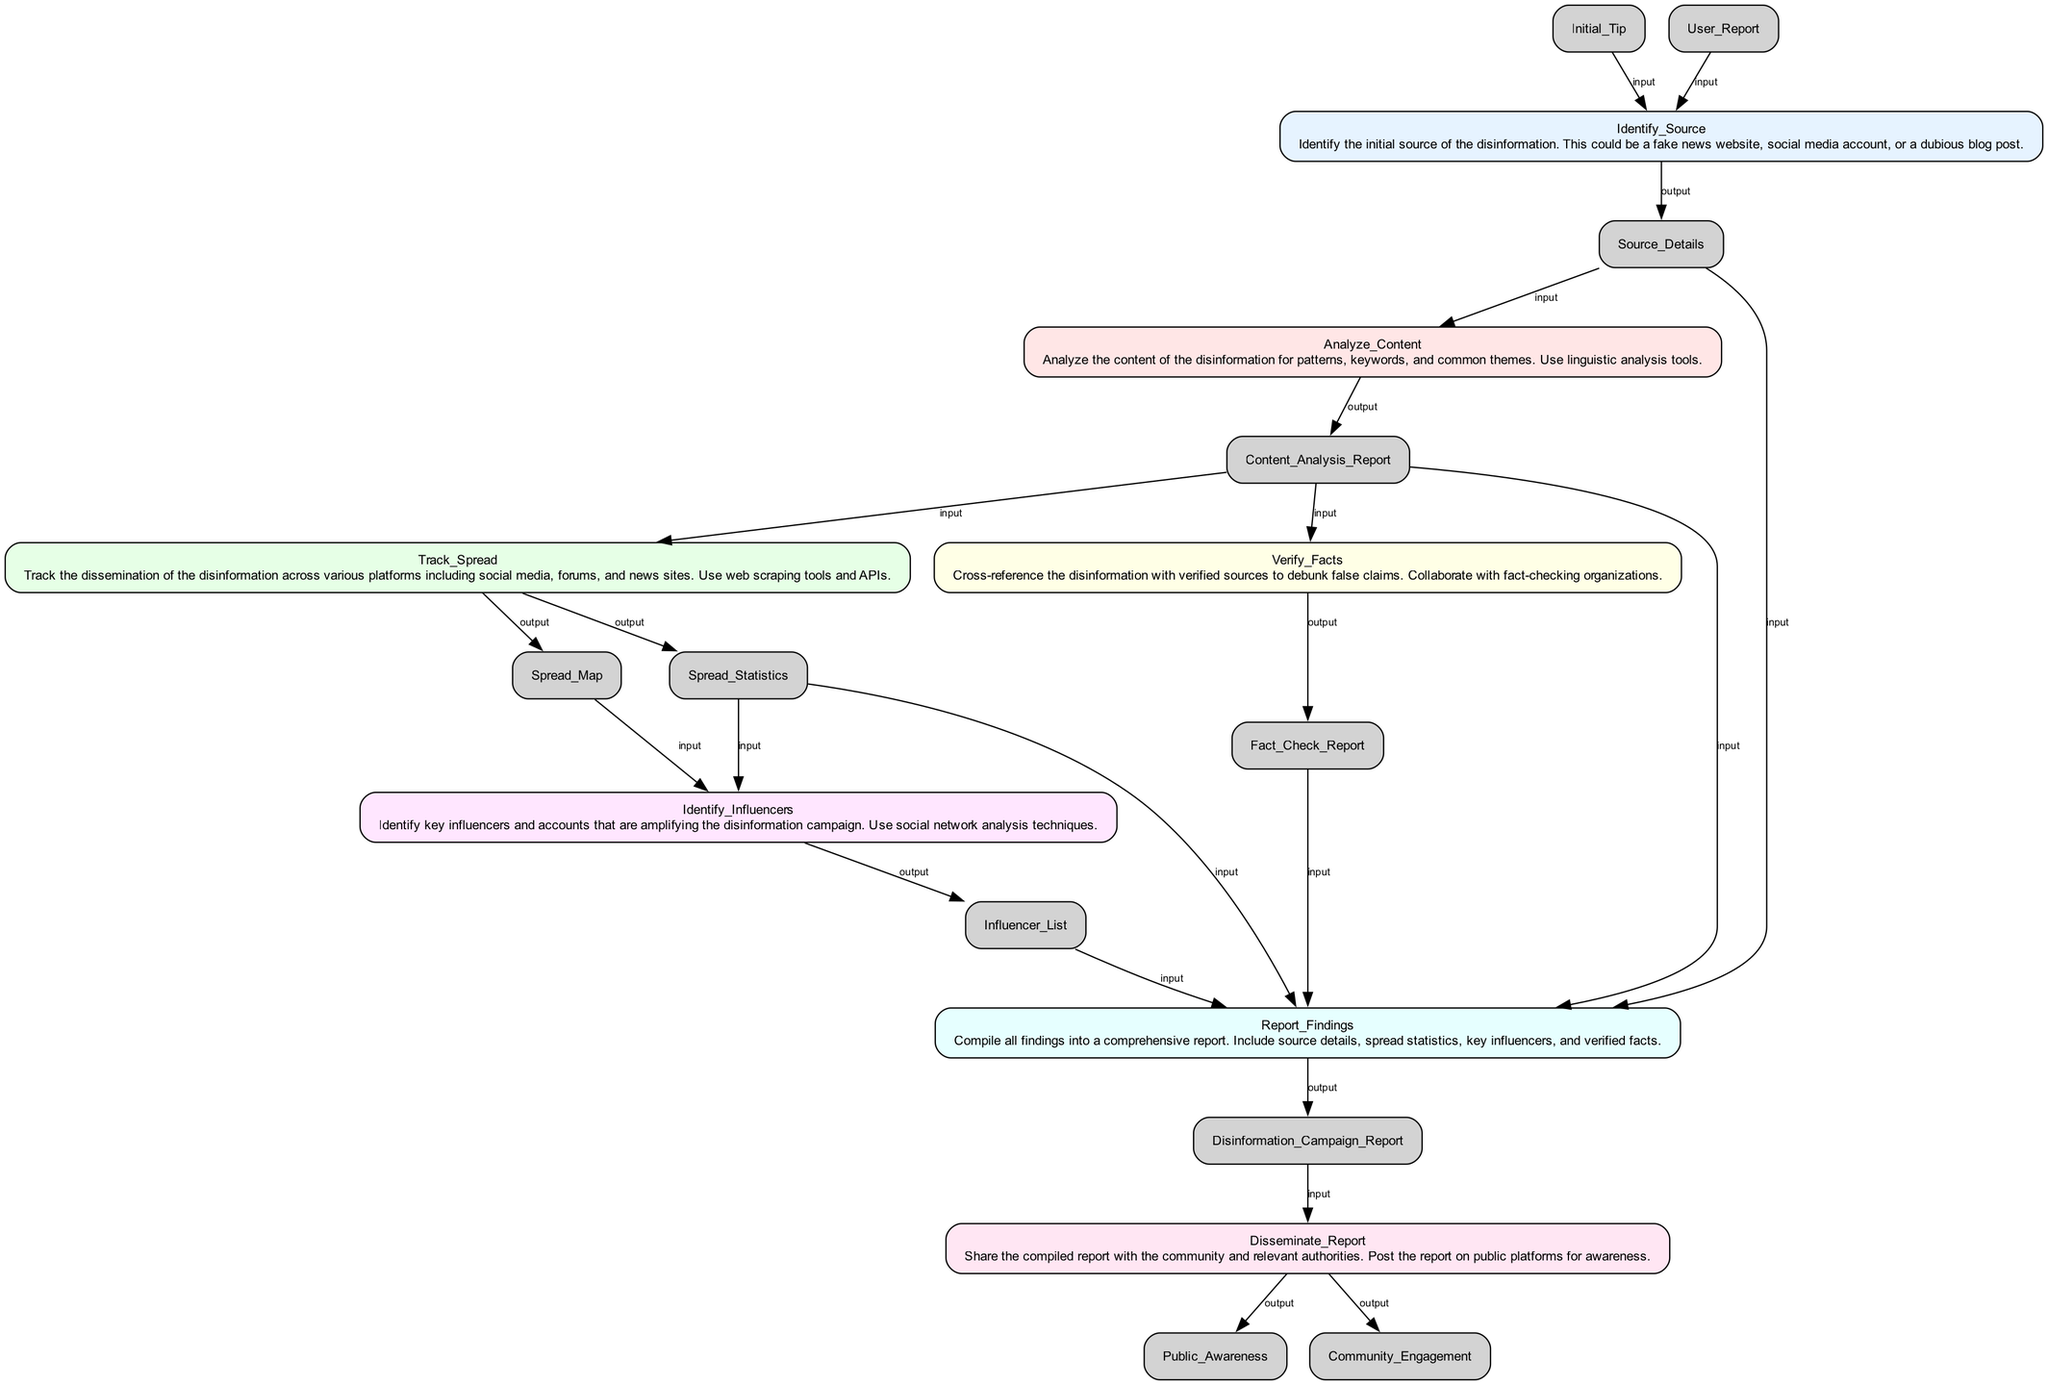What is the first step in the flowchart? The first step is "Identify_Source." It appears at the top of the flowchart and is the initial action taken in tracking the disinformation campaign.
Answer: Identify_Source How many elements are in the flowchart? There are a total of 7 elements listed in the flowchart, each corresponding to a step in the function of tracking disinformation.
Answer: 7 Which node produces the output "Fact_Check_Report"? The output "Fact_Check_Report" comes from the node "Verify_Facts," which uses the input "Content_Analysis_Report" to generate this report.
Answer: Verify_Facts What are the inputs for the "Track_Spread" step? The inputs for the "Track_Spread" step are "Content_Analysis_Report." This is the single item needed to analyze the spread of disinformation across platforms.
Answer: Content_Analysis_Report Which output is produced by the "Identify_Influencers" step? The "Identify_Influencers" step produces the output "Influencer_List," which identifies key accounts amplifying the disinformation campaign.
Answer: Influencer_List What is the relationship between "Analyze_Content" and "Track_Spread"? "Analyze_Content" outputs the "Content_Analysis_Report," which serves as an input for "Track_Spread," indicating a direct flow of information between these two nodes.
Answer: Flow of information How is the final report disseminated to the community? The final report is disseminated through the "Disseminate_Report" step, which outputs "Public_Awareness" and "Community_Engagement," highlighting the action taken to raise awareness.
Answer: Disseminate_Report Which node requires inputs from multiple previous nodes? The "Report_Findings" node requires inputs from multiple nodes including "Source_Details," "Content_Analysis_Report," "Spread_Statistics," "Influencer_List," and "Fact_Check_Report," demonstrating its comprehensive nature.
Answer: Report_Findings What analysis techniques are suggested for "Identify_Influencers"? The "Identify_Influencers" step suggests using social network analysis techniques to pinpoint influencers in the disinformation spread.
Answer: Social network analysis techniques 